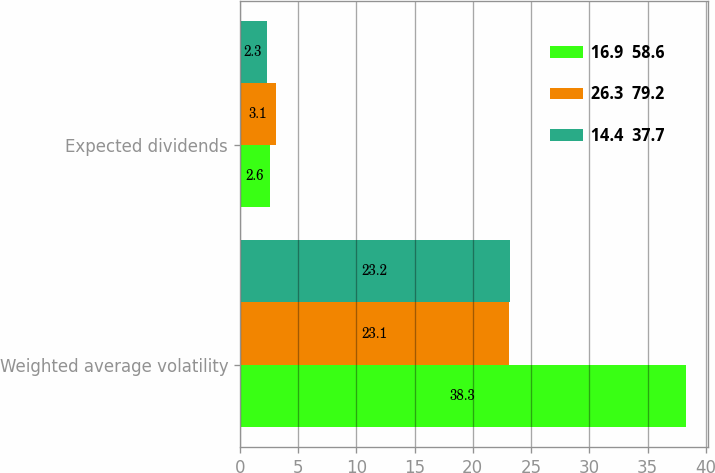Convert chart. <chart><loc_0><loc_0><loc_500><loc_500><stacked_bar_chart><ecel><fcel>Weighted average volatility<fcel>Expected dividends<nl><fcel>16.9  58.6<fcel>38.3<fcel>2.6<nl><fcel>26.3  79.2<fcel>23.1<fcel>3.1<nl><fcel>14.4  37.7<fcel>23.2<fcel>2.3<nl></chart> 